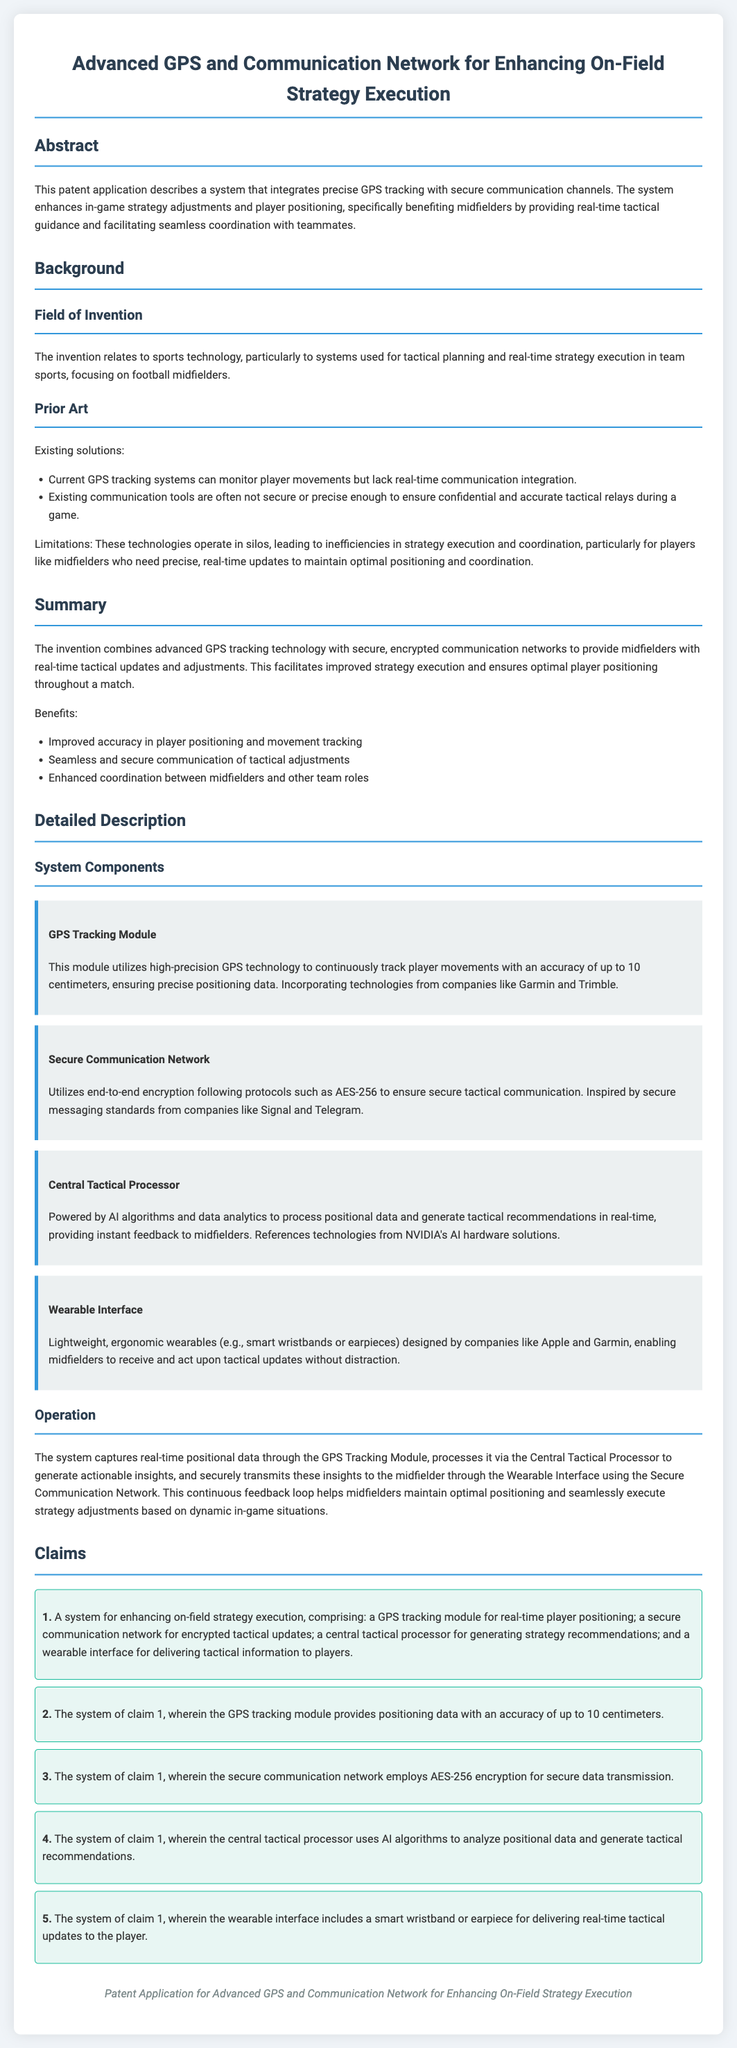What is the main purpose of the invention? The main purpose of the invention is to integrate precise GPS tracking with secure communication channels to enhance in-game strategy adjustments and player positioning.
Answer: enhance in-game strategy adjustments and player positioning What is the accuracy of the GPS tracking module? The document specifies that the GPS tracking module provides positioning data with an accuracy of up to 10 centimeters.
Answer: 10 centimeters Which encryption protocol does the secure communication network employ? The secure communication network utilizes AES-256 encryption for secure data transmission.
Answer: AES-256 What type of processor does the system use? The system uses a Central Tactical Processor powered by AI algorithms and data analytics.
Answer: Central Tactical Processor How does the system aid midfielders during a match? The system aids midfielders by providing real-time tactical updates and adjustments, facilitating improved strategy execution.
Answer: real-time tactical updates and adjustments What are the components of the system mentioned in the claims? The components of the system include a GPS tracking module, a secure communication network, a central tactical processor, and a wearable interface.
Answer: GPS tracking module, secure communication network, central tactical processor, wearable interface Which companies' technologies are referenced in the system components? The document references technologies from companies like Garmin, Trimble, Signal, Telegram, and NVIDIA.
Answer: Garmin, Trimble, Signal, Telegram, NVIDIA What type of interface is mentioned for delivering tactical information to players? A wearable interface is mentioned for delivering tactical information to players.
Answer: wearable interface 